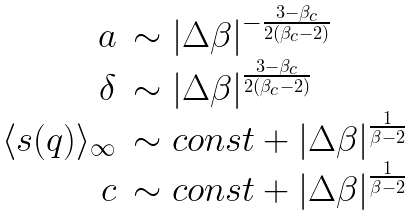Convert formula to latex. <formula><loc_0><loc_0><loc_500><loc_500>\begin{array} { r l } a & \sim | \Delta \beta | ^ { - \frac { 3 - \beta _ { c } } { 2 ( \beta _ { c } - 2 ) } } \\ \delta & \sim | \Delta \beta | ^ { \frac { 3 - \beta _ { c } } { 2 ( \beta _ { c } - 2 ) } } \\ \langle s ( q ) \rangle _ { \infty } & \sim c o n s t + | \Delta \beta | ^ { \frac { 1 } { \beta - 2 } } \\ c & \sim c o n s t + | \Delta \beta | ^ { \frac { 1 } { \beta - 2 } } \end{array}</formula> 